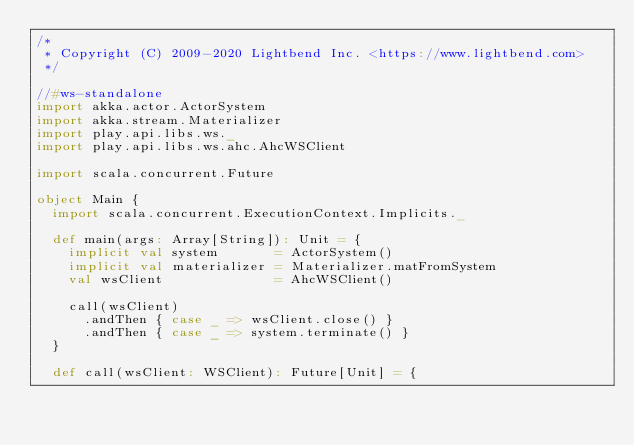Convert code to text. <code><loc_0><loc_0><loc_500><loc_500><_Scala_>/*
 * Copyright (C) 2009-2020 Lightbend Inc. <https://www.lightbend.com>
 */

//#ws-standalone
import akka.actor.ActorSystem
import akka.stream.Materializer
import play.api.libs.ws._
import play.api.libs.ws.ahc.AhcWSClient

import scala.concurrent.Future

object Main {
  import scala.concurrent.ExecutionContext.Implicits._

  def main(args: Array[String]): Unit = {
    implicit val system       = ActorSystem()
    implicit val materializer = Materializer.matFromSystem
    val wsClient              = AhcWSClient()

    call(wsClient)
      .andThen { case _ => wsClient.close() }
      .andThen { case _ => system.terminate() }
  }

  def call(wsClient: WSClient): Future[Unit] = {</code> 